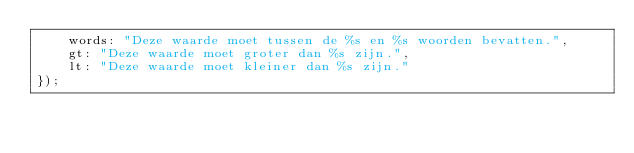Convert code to text. <code><loc_0><loc_0><loc_500><loc_500><_JavaScript_>    words: "Deze waarde moet tussen de %s en %s woorden bevatten.",
    gt: "Deze waarde moet groter dan %s zijn.",
    lt: "Deze waarde moet kleiner dan %s zijn."
});
</code> 